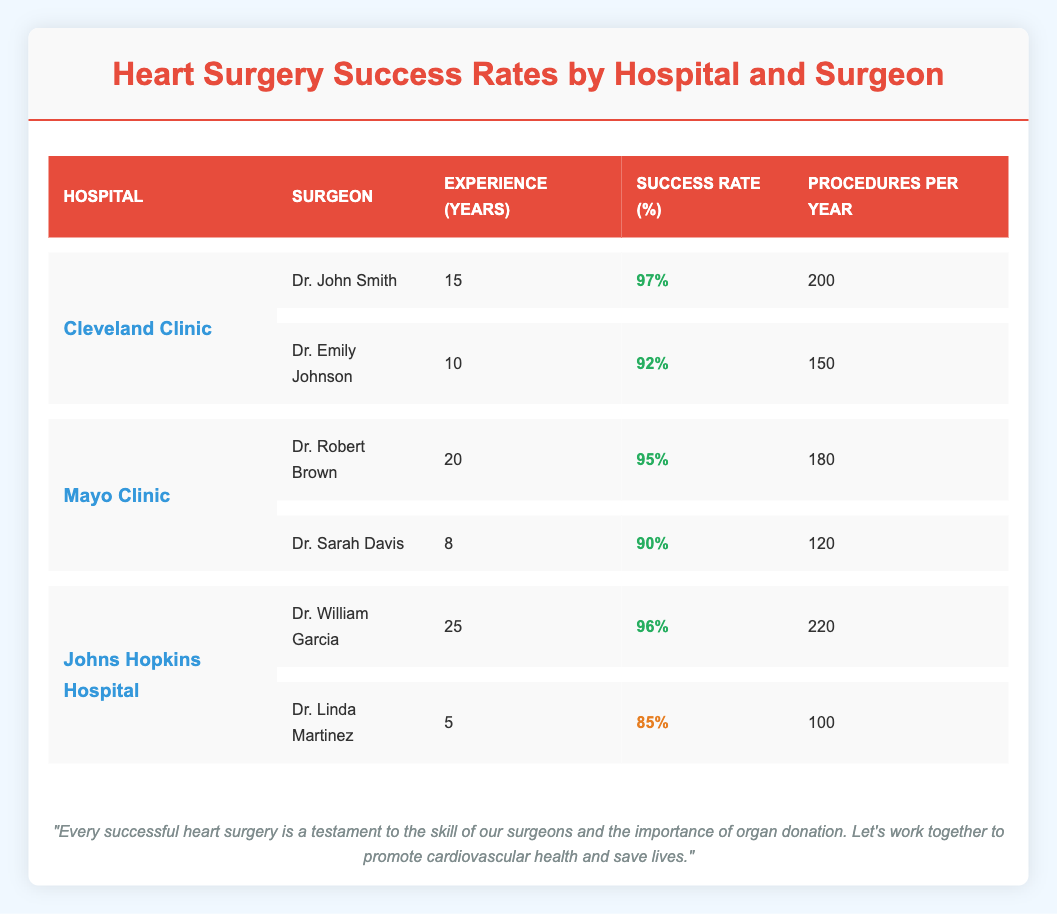What is the success rate of Dr. John Smith? From the table, Dr. John Smith's success rate is clearly indicated as 97%.
Answer: 97% Which surgeon has the highest experience among the listed surgeons? The surgeon with the highest experience is Dr. William Garcia, who has 25 years of experience.
Answer: Dr. William Garcia Is Dr. Linda Martinez's success rate higher than Dr. Emily Johnson's? Dr. Linda Martinez's success rate is 85%, while Dr. Emily Johnson's is 92%. Since 85% is less than 92%, the statement is false.
Answer: No What is the average success rate of surgeons at Mayo Clinic? To calculate the average, add the success rates: (95% + 90%) / 2 = 185% / 2 = 92.5%.
Answer: 92.5% How many procedures does Dr. Robert Brown perform per year compared to Dr. Emily Johnson? Dr. Robert Brown performs 180 procedures per year and Dr. Emily Johnson performs 150. The difference is 180 - 150 = 30.
Answer: 30 Which hospital has the lowest success rate among the listed surgeons? Comparing the success rates, Dr. Linda Martinez has the lowest success rate at 85%. Therefore, Johns Hopkins Hospital has the lowest success rate.
Answer: Johns Hopkins Hospital How many total procedures per year do all surgeons at Cleveland Clinic perform? The total procedures can be calculated as follows: 200 (Dr. John Smith) + 150 (Dr. Emily Johnson) = 350 procedures per year.
Answer: 350 What percentage of surgeons at Johns Hopkins have more than 20 years of experience? Among the two surgeons at Johns Hopkins, only Dr. William Garcia has more than 20 years of experience (25 years). Therefore, 1 out of 2 = 50%.
Answer: 50% 